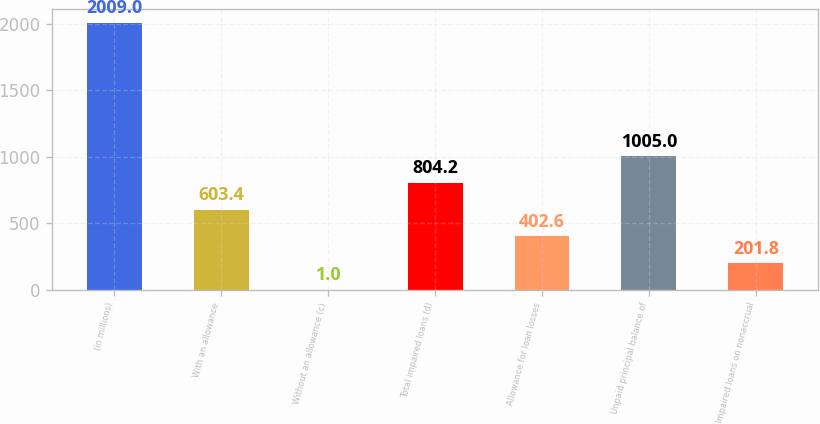<chart> <loc_0><loc_0><loc_500><loc_500><bar_chart><fcel>(in millions)<fcel>With an allowance<fcel>Without an allowance (c)<fcel>Total impaired loans (d)<fcel>Allowance for loan losses<fcel>Unpaid principal balance of<fcel>Impaired loans on nonaccrual<nl><fcel>2009<fcel>603.4<fcel>1<fcel>804.2<fcel>402.6<fcel>1005<fcel>201.8<nl></chart> 